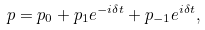<formula> <loc_0><loc_0><loc_500><loc_500>p = p _ { 0 } + p _ { 1 } e ^ { - i \delta t } + p _ { - 1 } e ^ { i \delta t } ,</formula> 